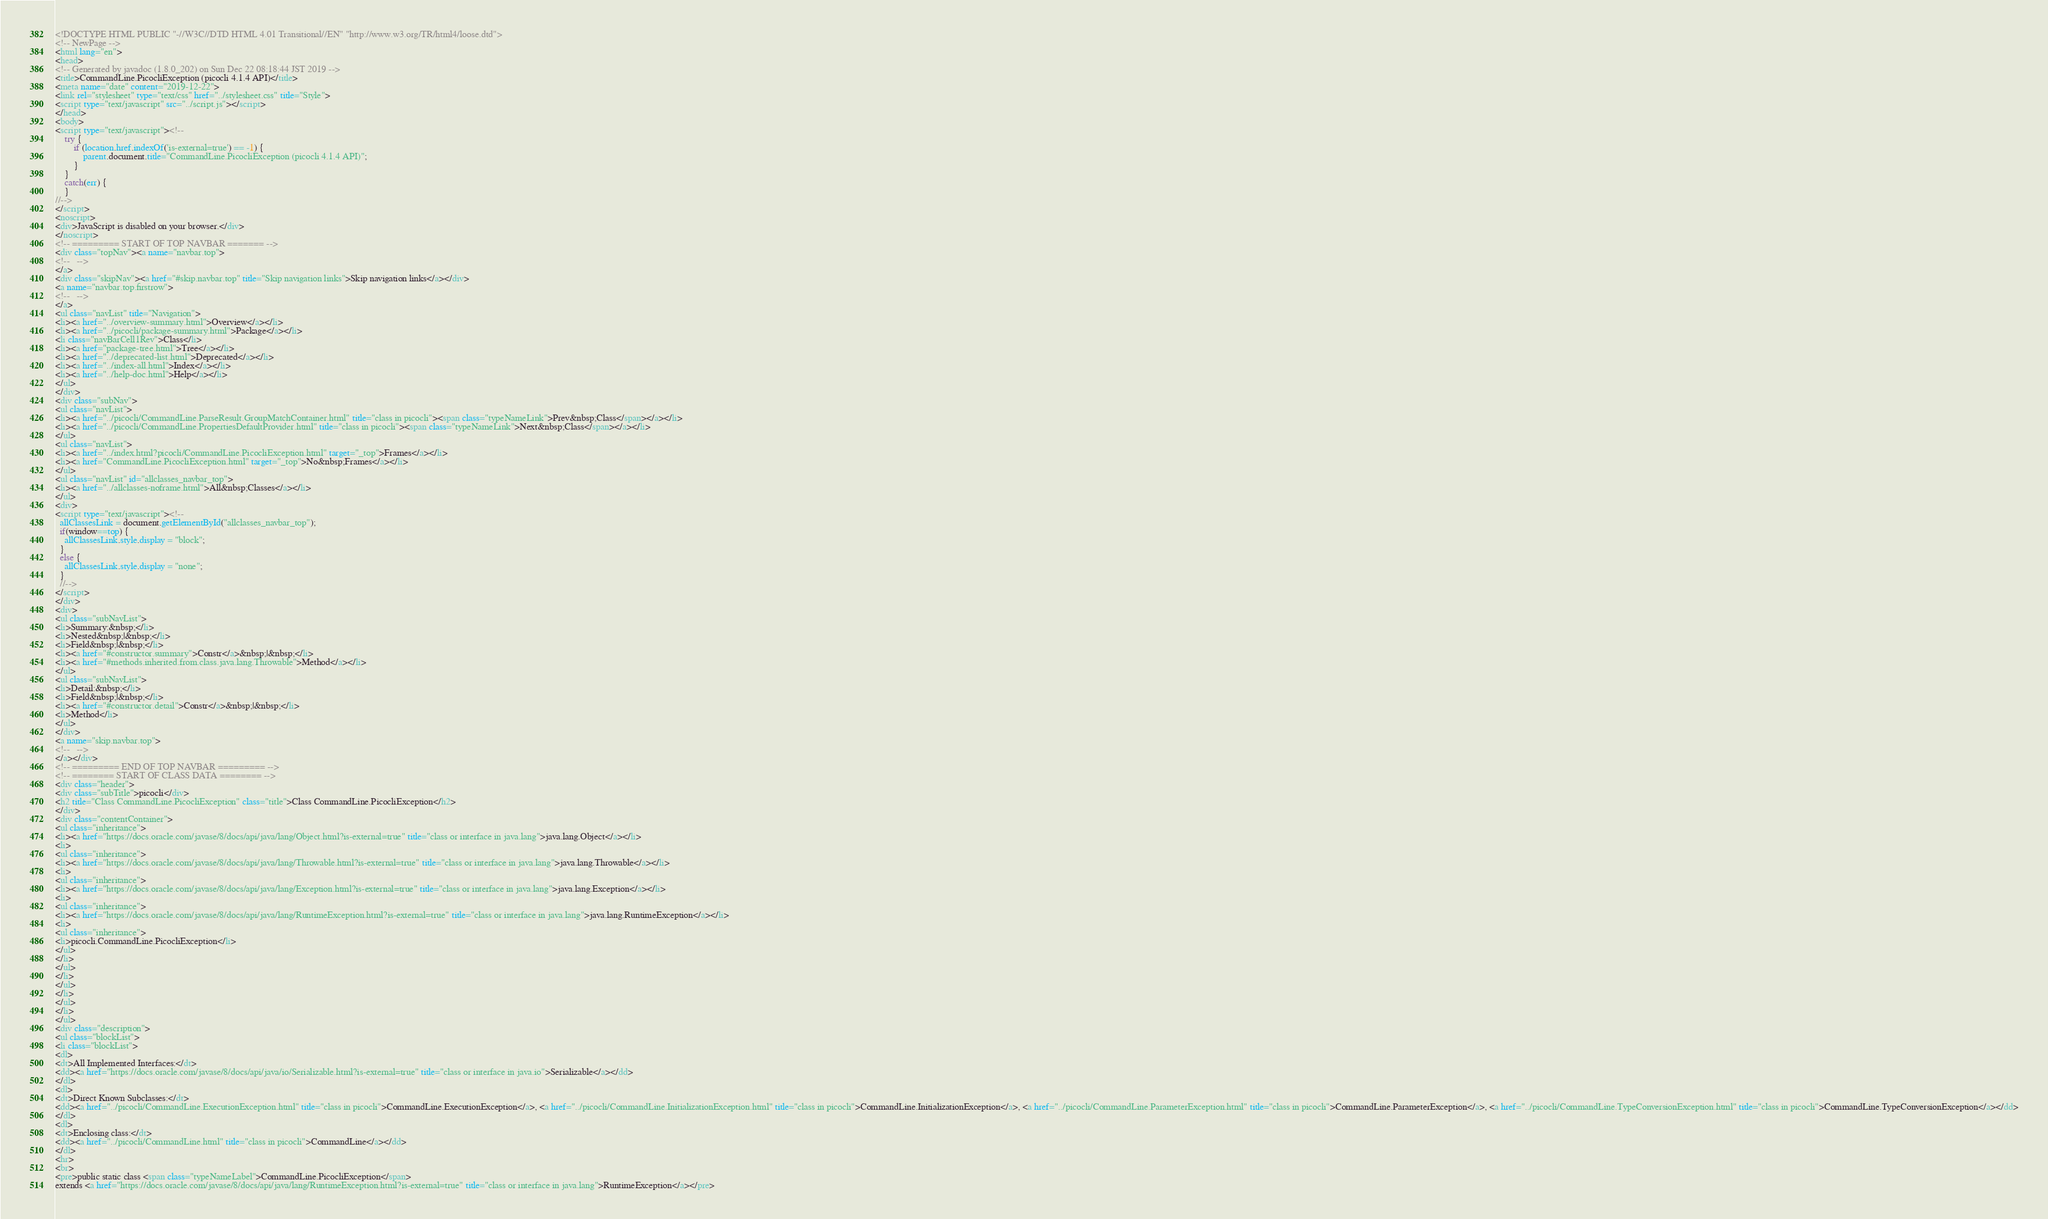<code> <loc_0><loc_0><loc_500><loc_500><_HTML_><!DOCTYPE HTML PUBLIC "-//W3C//DTD HTML 4.01 Transitional//EN" "http://www.w3.org/TR/html4/loose.dtd">
<!-- NewPage -->
<html lang="en">
<head>
<!-- Generated by javadoc (1.8.0_202) on Sun Dec 22 08:18:44 JST 2019 -->
<title>CommandLine.PicocliException (picocli 4.1.4 API)</title>
<meta name="date" content="2019-12-22">
<link rel="stylesheet" type="text/css" href="../stylesheet.css" title="Style">
<script type="text/javascript" src="../script.js"></script>
</head>
<body>
<script type="text/javascript"><!--
    try {
        if (location.href.indexOf('is-external=true') == -1) {
            parent.document.title="CommandLine.PicocliException (picocli 4.1.4 API)";
        }
    }
    catch(err) {
    }
//-->
</script>
<noscript>
<div>JavaScript is disabled on your browser.</div>
</noscript>
<!-- ========= START OF TOP NAVBAR ======= -->
<div class="topNav"><a name="navbar.top">
<!--   -->
</a>
<div class="skipNav"><a href="#skip.navbar.top" title="Skip navigation links">Skip navigation links</a></div>
<a name="navbar.top.firstrow">
<!--   -->
</a>
<ul class="navList" title="Navigation">
<li><a href="../overview-summary.html">Overview</a></li>
<li><a href="../picocli/package-summary.html">Package</a></li>
<li class="navBarCell1Rev">Class</li>
<li><a href="package-tree.html">Tree</a></li>
<li><a href="../deprecated-list.html">Deprecated</a></li>
<li><a href="../index-all.html">Index</a></li>
<li><a href="../help-doc.html">Help</a></li>
</ul>
</div>
<div class="subNav">
<ul class="navList">
<li><a href="../picocli/CommandLine.ParseResult.GroupMatchContainer.html" title="class in picocli"><span class="typeNameLink">Prev&nbsp;Class</span></a></li>
<li><a href="../picocli/CommandLine.PropertiesDefaultProvider.html" title="class in picocli"><span class="typeNameLink">Next&nbsp;Class</span></a></li>
</ul>
<ul class="navList">
<li><a href="../index.html?picocli/CommandLine.PicocliException.html" target="_top">Frames</a></li>
<li><a href="CommandLine.PicocliException.html" target="_top">No&nbsp;Frames</a></li>
</ul>
<ul class="navList" id="allclasses_navbar_top">
<li><a href="../allclasses-noframe.html">All&nbsp;Classes</a></li>
</ul>
<div>
<script type="text/javascript"><!--
  allClassesLink = document.getElementById("allclasses_navbar_top");
  if(window==top) {
    allClassesLink.style.display = "block";
  }
  else {
    allClassesLink.style.display = "none";
  }
  //-->
</script>
</div>
<div>
<ul class="subNavList">
<li>Summary:&nbsp;</li>
<li>Nested&nbsp;|&nbsp;</li>
<li>Field&nbsp;|&nbsp;</li>
<li><a href="#constructor.summary">Constr</a>&nbsp;|&nbsp;</li>
<li><a href="#methods.inherited.from.class.java.lang.Throwable">Method</a></li>
</ul>
<ul class="subNavList">
<li>Detail:&nbsp;</li>
<li>Field&nbsp;|&nbsp;</li>
<li><a href="#constructor.detail">Constr</a>&nbsp;|&nbsp;</li>
<li>Method</li>
</ul>
</div>
<a name="skip.navbar.top">
<!--   -->
</a></div>
<!-- ========= END OF TOP NAVBAR ========= -->
<!-- ======== START OF CLASS DATA ======== -->
<div class="header">
<div class="subTitle">picocli</div>
<h2 title="Class CommandLine.PicocliException" class="title">Class CommandLine.PicocliException</h2>
</div>
<div class="contentContainer">
<ul class="inheritance">
<li><a href="https://docs.oracle.com/javase/8/docs/api/java/lang/Object.html?is-external=true" title="class or interface in java.lang">java.lang.Object</a></li>
<li>
<ul class="inheritance">
<li><a href="https://docs.oracle.com/javase/8/docs/api/java/lang/Throwable.html?is-external=true" title="class or interface in java.lang">java.lang.Throwable</a></li>
<li>
<ul class="inheritance">
<li><a href="https://docs.oracle.com/javase/8/docs/api/java/lang/Exception.html?is-external=true" title="class or interface in java.lang">java.lang.Exception</a></li>
<li>
<ul class="inheritance">
<li><a href="https://docs.oracle.com/javase/8/docs/api/java/lang/RuntimeException.html?is-external=true" title="class or interface in java.lang">java.lang.RuntimeException</a></li>
<li>
<ul class="inheritance">
<li>picocli.CommandLine.PicocliException</li>
</ul>
</li>
</ul>
</li>
</ul>
</li>
</ul>
</li>
</ul>
<div class="description">
<ul class="blockList">
<li class="blockList">
<dl>
<dt>All Implemented Interfaces:</dt>
<dd><a href="https://docs.oracle.com/javase/8/docs/api/java/io/Serializable.html?is-external=true" title="class or interface in java.io">Serializable</a></dd>
</dl>
<dl>
<dt>Direct Known Subclasses:</dt>
<dd><a href="../picocli/CommandLine.ExecutionException.html" title="class in picocli">CommandLine.ExecutionException</a>, <a href="../picocli/CommandLine.InitializationException.html" title="class in picocli">CommandLine.InitializationException</a>, <a href="../picocli/CommandLine.ParameterException.html" title="class in picocli">CommandLine.ParameterException</a>, <a href="../picocli/CommandLine.TypeConversionException.html" title="class in picocli">CommandLine.TypeConversionException</a></dd>
</dl>
<dl>
<dt>Enclosing class:</dt>
<dd><a href="../picocli/CommandLine.html" title="class in picocli">CommandLine</a></dd>
</dl>
<hr>
<br>
<pre>public static class <span class="typeNameLabel">CommandLine.PicocliException</span>
extends <a href="https://docs.oracle.com/javase/8/docs/api/java/lang/RuntimeException.html?is-external=true" title="class or interface in java.lang">RuntimeException</a></pre></code> 